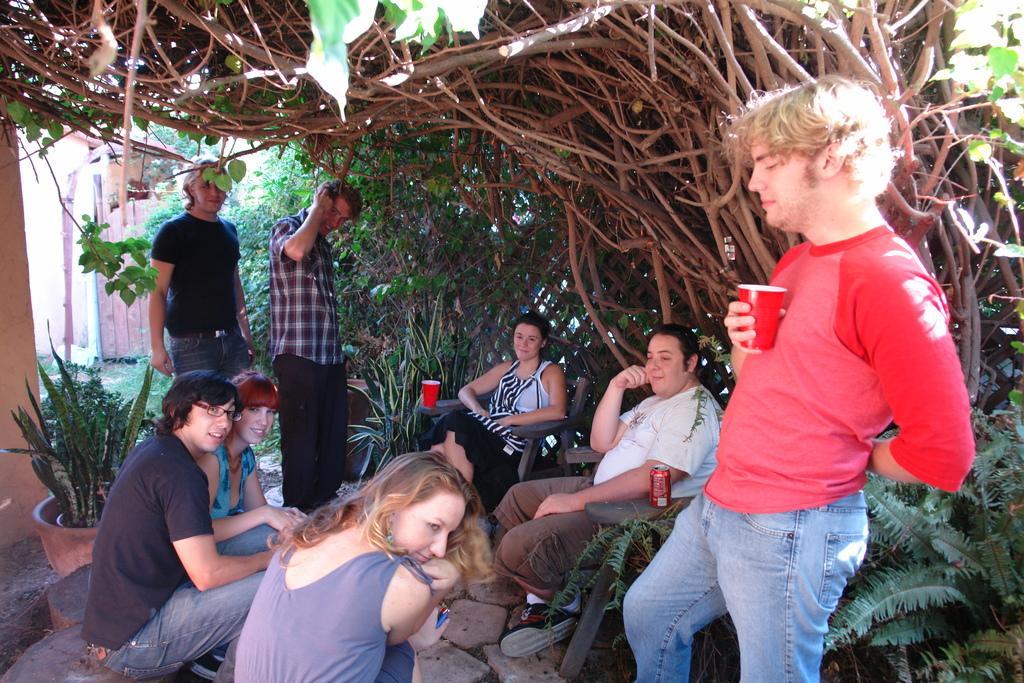Describe this image in one or two sentences. In this picture, we can see a few people, among them a few are sitting, a few are standing and some are holding some objects, and we can see the ground, stones, plant in pots, trees, and the wall with door. 